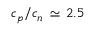Convert formula to latex. <formula><loc_0><loc_0><loc_500><loc_500>c _ { p } / c _ { n } \, \simeq \, 2 . 5</formula> 